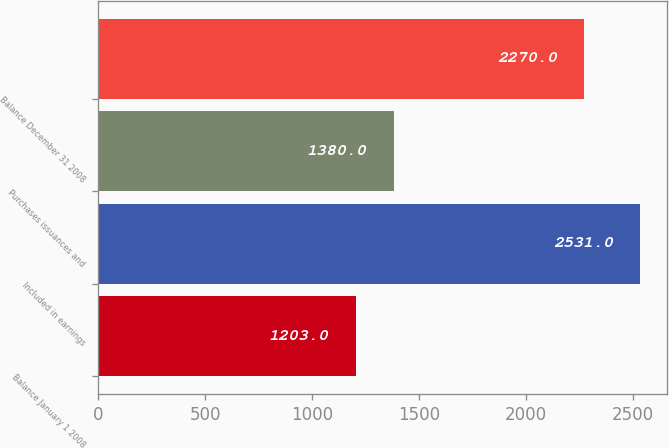Convert chart. <chart><loc_0><loc_0><loc_500><loc_500><bar_chart><fcel>Balance January 1 2008<fcel>Included in earnings<fcel>Purchases issuances and<fcel>Balance December 31 2008<nl><fcel>1203<fcel>2531<fcel>1380<fcel>2270<nl></chart> 